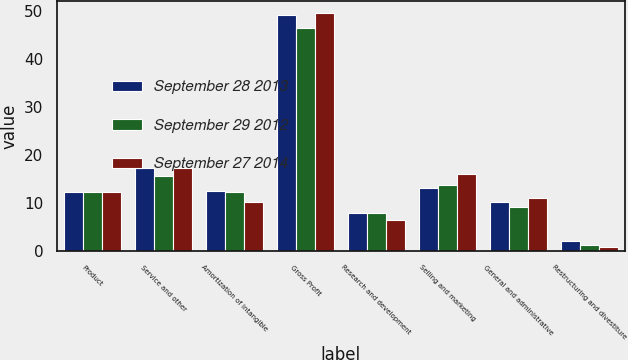<chart> <loc_0><loc_0><loc_500><loc_500><stacked_bar_chart><ecel><fcel>Product<fcel>Service and other<fcel>Amortization of intangible<fcel>Gross Profit<fcel>Research and development<fcel>Selling and marketing<fcel>General and administrative<fcel>Restructuring and divestiture<nl><fcel>September 28 2013<fcel>12.3<fcel>17.2<fcel>12.4<fcel>49.2<fcel>8<fcel>13.1<fcel>10.3<fcel>2<nl><fcel>September 29 2012<fcel>12.3<fcel>15.7<fcel>12.3<fcel>46.6<fcel>7.9<fcel>13.7<fcel>9.1<fcel>1.3<nl><fcel>September 27 2014<fcel>12.3<fcel>17.2<fcel>10.1<fcel>49.7<fcel>6.5<fcel>16.1<fcel>11<fcel>0.9<nl></chart> 